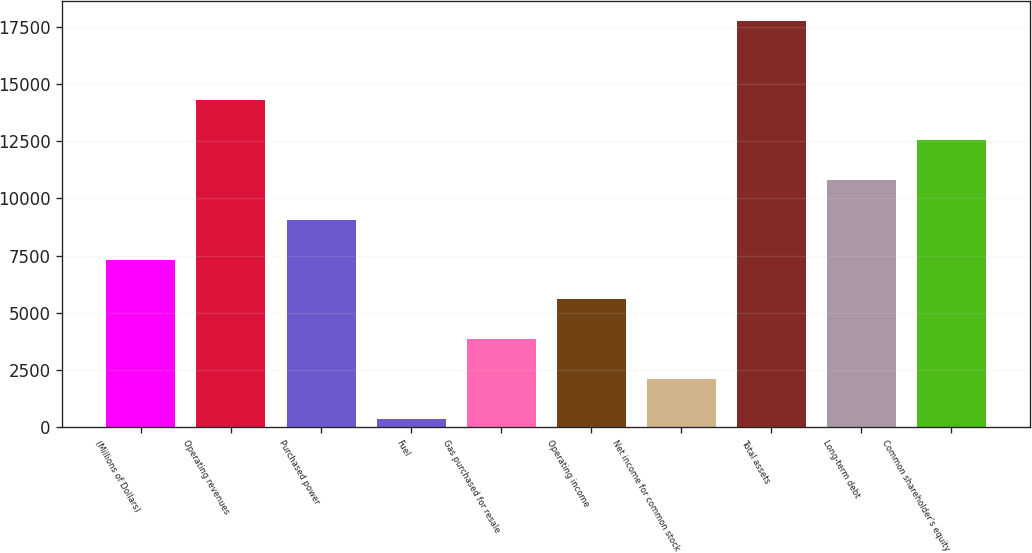Convert chart to OTSL. <chart><loc_0><loc_0><loc_500><loc_500><bar_chart><fcel>(Millions of Dollars)<fcel>Operating revenues<fcel>Purchased power<fcel>Fuel<fcel>Gas purchased for resale<fcel>Operating income<fcel>Net income for common stock<fcel>Total assets<fcel>Long-term debt<fcel>Common shareholder's equity<nl><fcel>7320.4<fcel>14282.8<fcel>9061<fcel>358<fcel>3839.2<fcel>5579.8<fcel>2098.6<fcel>17764<fcel>10801.6<fcel>12542.2<nl></chart> 